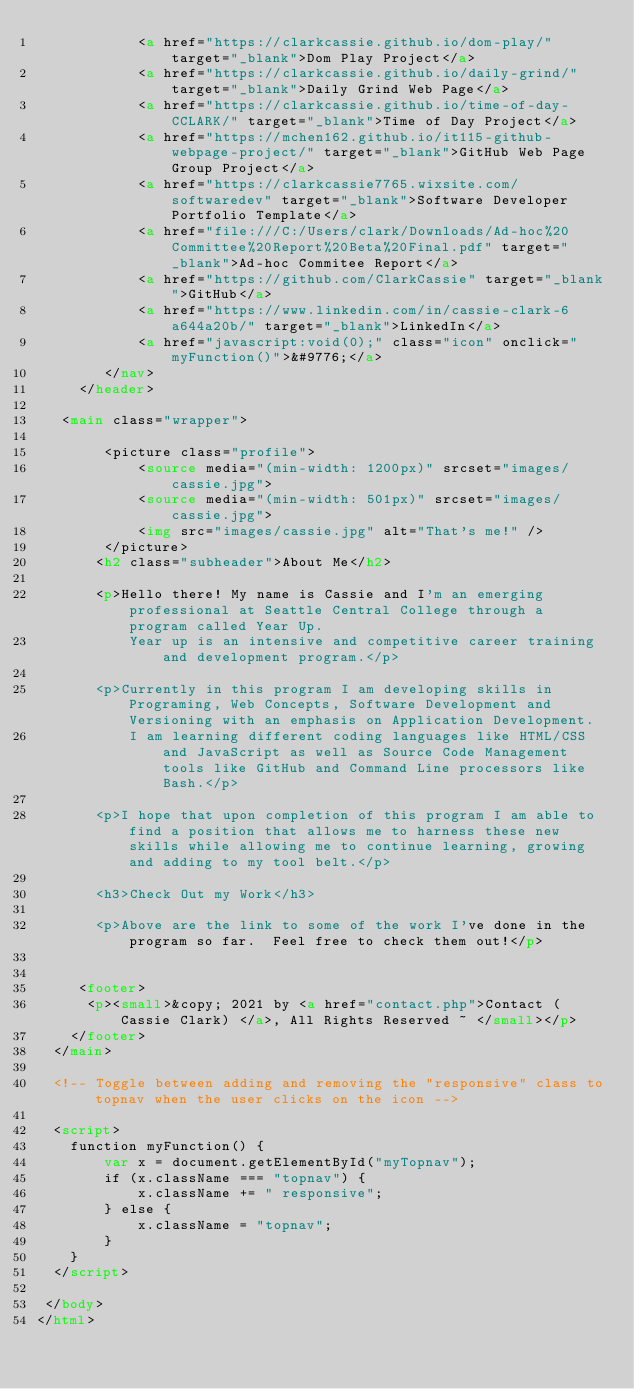<code> <loc_0><loc_0><loc_500><loc_500><_HTML_>            <a href="https://clarkcassie.github.io/dom-play/" target="_blank">Dom Play Project</a>
            <a href="https://clarkcassie.github.io/daily-grind/" target="_blank">Daily Grind Web Page</a>
            <a href="https://clarkcassie.github.io/time-of-day-CCLARK/" target="_blank">Time of Day Project</a>
            <a href="https://mchen162.github.io/it115-github-webpage-project/" target="_blank">GitHub Web Page Group Project</a>
            <a href="https://clarkcassie7765.wixsite.com/softwaredev" target="_blank">Software Developer Portfolio Template</a>
            <a href="file:///C:/Users/clark/Downloads/Ad-hoc%20Committee%20Report%20Beta%20Final.pdf" target="_blank">Ad-hoc Commitee Report</a>
            <a href="https://github.com/ClarkCassie" target="_blank">GitHub</a>
            <a href="https://www.linkedin.com/in/cassie-clark-6a644a20b/" target="_blank">LinkedIn</a>
            <a href="javascript:void(0);" class="icon" onclick="myFunction()">&#9776;</a>
        </nav>
     </header>
     
   <main class="wrapper">
   
        <picture class="profile">
            <source media="(min-width: 1200px)" srcset="images/cassie.jpg">
            <source media="(min-width: 501px)" srcset="images/cassie.jpg">
            <img src="images/cassie.jpg" alt="That's me!" />
        </picture>   
       <h2 class="subheader">About Me</h2>
       
       <p>Hello there! My name is Cassie and I'm an emerging professional at Seattle Central College through a program called Year Up. 
           Year up is an intensive and competitive career training and development program.</p>
       
       <p>Currently in this program I am developing skills in Programing, Web Concepts, Software Development and Versioning with an emphasis on Application Development. 
           I am learning different coding languages like HTML/CSS and JavaScript as well as Source Code Management tools like GitHub and Command Line processors like Bash.</p>
       
       <p>I hope that upon completion of this program I am able to find a position that allows me to harness these new skills while allowing me to continue learning, growing and adding to my tool belt.</p>

       <h3>Check Out my Work</h3>

       <p>Above are the link to some of the work I've done in the program so far.  Feel free to check them out!</p>


     <footer>
      <p><small>&copy; 2021 by <a href="contact.php">Contact (Cassie Clark) </a>, All Rights Reserved ~ </small></p>
    </footer>
  </main>
     
  <!-- Toggle between adding and removing the "responsive" class to topnav when the user clicks on the icon -->
     
  <script>
    function myFunction() {
        var x = document.getElementById("myTopnav");
        if (x.className === "topnav") {
            x.className += " responsive";
        } else {
            x.className = "topnav";
        }
    }   
  </script>
     
 </body>
</html>
</code> 